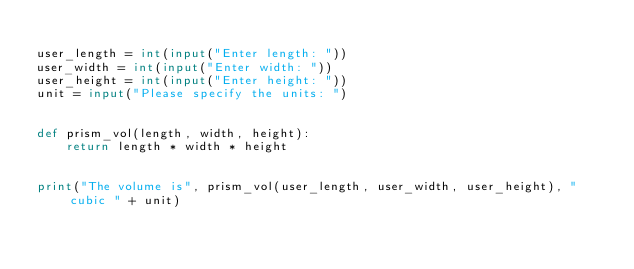<code> <loc_0><loc_0><loc_500><loc_500><_Python_>
user_length = int(input("Enter length: "))
user_width = int(input("Enter width: "))
user_height = int(input("Enter height: "))
unit = input("Please specify the units: ")


def prism_vol(length, width, height):
    return length * width * height


print("The volume is", prism_vol(user_length, user_width, user_height), "cubic " + unit)
</code> 